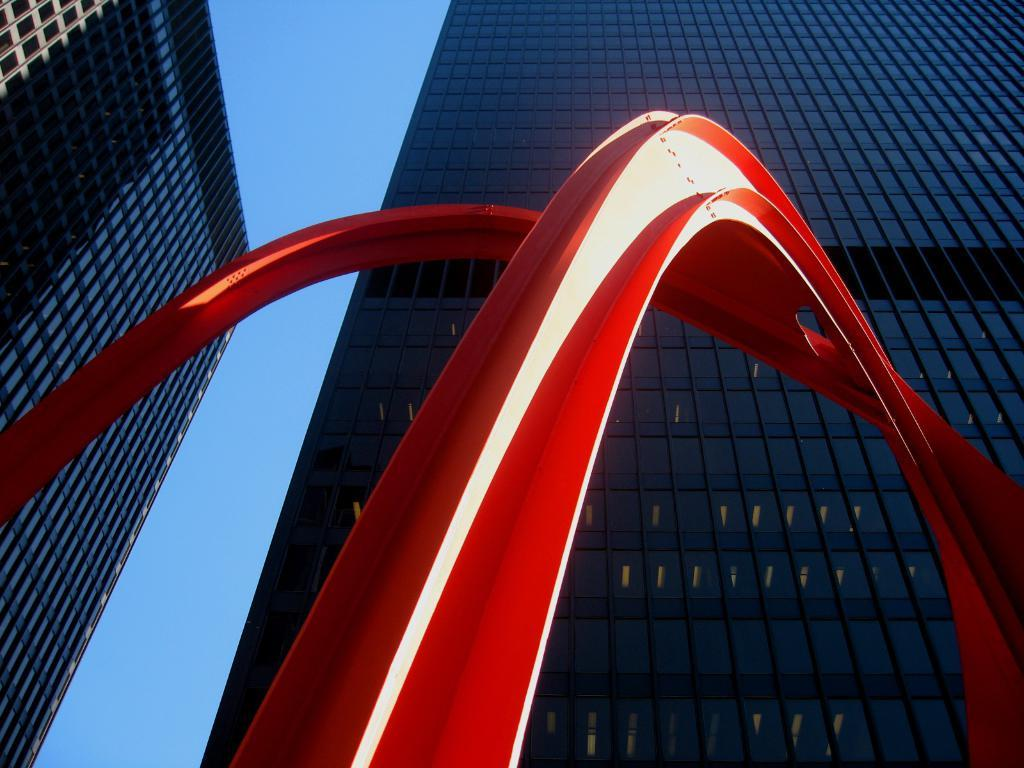What is the main subject in the center of the image? There is a sculpture in the center of the image. What can be seen in the background of the image? There are buildings and the sky visible in the background of the image. What type of seed is being used to create the honey in the image? There is no seed or honey present in the image; it features a sculpture and buildings in the background. 